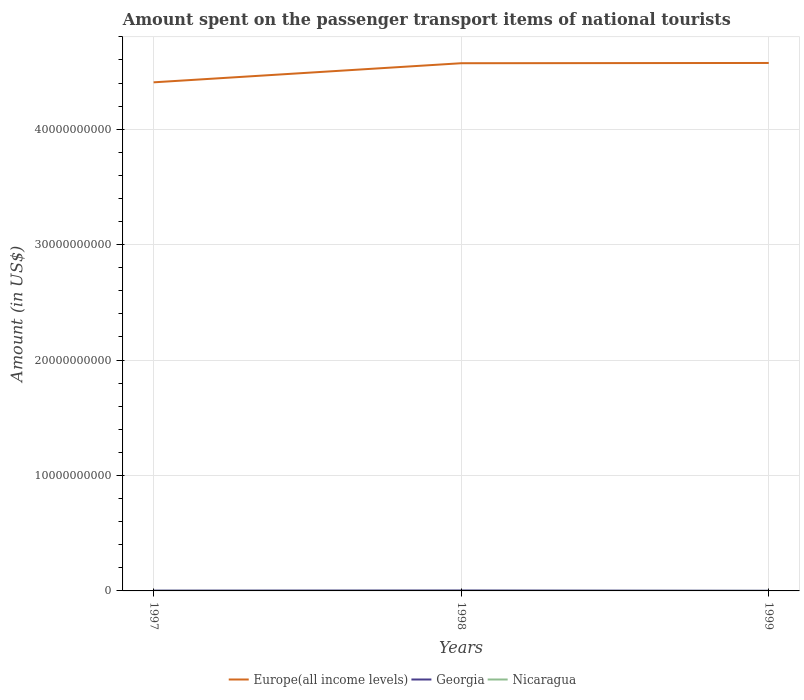Does the line corresponding to Georgia intersect with the line corresponding to Europe(all income levels)?
Keep it short and to the point. No. Across all years, what is the maximum amount spent on the passenger transport items of national tourists in Georgia?
Your answer should be compact. 1.30e+07. What is the total amount spent on the passenger transport items of national tourists in Georgia in the graph?
Keep it short and to the point. 2.80e+07. What is the difference between the highest and the second highest amount spent on the passenger transport items of national tourists in Georgia?
Ensure brevity in your answer.  2.80e+07. Is the amount spent on the passenger transport items of national tourists in Europe(all income levels) strictly greater than the amount spent on the passenger transport items of national tourists in Georgia over the years?
Your response must be concise. No. How many years are there in the graph?
Provide a succinct answer. 3. What is the difference between two consecutive major ticks on the Y-axis?
Offer a terse response. 1.00e+1. Are the values on the major ticks of Y-axis written in scientific E-notation?
Offer a very short reply. No. Does the graph contain any zero values?
Your response must be concise. No. Does the graph contain grids?
Your answer should be very brief. Yes. How are the legend labels stacked?
Keep it short and to the point. Horizontal. What is the title of the graph?
Offer a very short reply. Amount spent on the passenger transport items of national tourists. What is the label or title of the Y-axis?
Provide a short and direct response. Amount (in US$). What is the Amount (in US$) of Europe(all income levels) in 1997?
Provide a succinct answer. 4.41e+1. What is the Amount (in US$) of Georgia in 1997?
Provide a succinct answer. 2.80e+07. What is the Amount (in US$) of Europe(all income levels) in 1998?
Your response must be concise. 4.57e+1. What is the Amount (in US$) in Georgia in 1998?
Provide a succinct answer. 4.10e+07. What is the Amount (in US$) of Europe(all income levels) in 1999?
Keep it short and to the point. 4.57e+1. What is the Amount (in US$) of Georgia in 1999?
Provide a succinct answer. 1.30e+07. What is the Amount (in US$) of Nicaragua in 1999?
Make the answer very short. 3.00e+06. Across all years, what is the maximum Amount (in US$) of Europe(all income levels)?
Make the answer very short. 4.57e+1. Across all years, what is the maximum Amount (in US$) of Georgia?
Provide a succinct answer. 4.10e+07. Across all years, what is the minimum Amount (in US$) in Europe(all income levels)?
Ensure brevity in your answer.  4.41e+1. Across all years, what is the minimum Amount (in US$) of Georgia?
Your answer should be compact. 1.30e+07. What is the total Amount (in US$) of Europe(all income levels) in the graph?
Offer a terse response. 1.36e+11. What is the total Amount (in US$) in Georgia in the graph?
Your response must be concise. 8.20e+07. What is the difference between the Amount (in US$) of Europe(all income levels) in 1997 and that in 1998?
Your answer should be very brief. -1.66e+09. What is the difference between the Amount (in US$) of Georgia in 1997 and that in 1998?
Offer a terse response. -1.30e+07. What is the difference between the Amount (in US$) of Nicaragua in 1997 and that in 1998?
Give a very brief answer. -1.00e+06. What is the difference between the Amount (in US$) in Europe(all income levels) in 1997 and that in 1999?
Offer a very short reply. -1.68e+09. What is the difference between the Amount (in US$) in Georgia in 1997 and that in 1999?
Your answer should be compact. 1.50e+07. What is the difference between the Amount (in US$) of Europe(all income levels) in 1998 and that in 1999?
Keep it short and to the point. -2.19e+07. What is the difference between the Amount (in US$) in Georgia in 1998 and that in 1999?
Offer a very short reply. 2.80e+07. What is the difference between the Amount (in US$) of Europe(all income levels) in 1997 and the Amount (in US$) of Georgia in 1998?
Give a very brief answer. 4.40e+1. What is the difference between the Amount (in US$) of Europe(all income levels) in 1997 and the Amount (in US$) of Nicaragua in 1998?
Offer a very short reply. 4.41e+1. What is the difference between the Amount (in US$) in Georgia in 1997 and the Amount (in US$) in Nicaragua in 1998?
Ensure brevity in your answer.  2.50e+07. What is the difference between the Amount (in US$) in Europe(all income levels) in 1997 and the Amount (in US$) in Georgia in 1999?
Your response must be concise. 4.40e+1. What is the difference between the Amount (in US$) of Europe(all income levels) in 1997 and the Amount (in US$) of Nicaragua in 1999?
Your answer should be compact. 4.41e+1. What is the difference between the Amount (in US$) of Georgia in 1997 and the Amount (in US$) of Nicaragua in 1999?
Make the answer very short. 2.50e+07. What is the difference between the Amount (in US$) in Europe(all income levels) in 1998 and the Amount (in US$) in Georgia in 1999?
Keep it short and to the point. 4.57e+1. What is the difference between the Amount (in US$) in Europe(all income levels) in 1998 and the Amount (in US$) in Nicaragua in 1999?
Provide a succinct answer. 4.57e+1. What is the difference between the Amount (in US$) in Georgia in 1998 and the Amount (in US$) in Nicaragua in 1999?
Offer a terse response. 3.80e+07. What is the average Amount (in US$) of Europe(all income levels) per year?
Make the answer very short. 4.52e+1. What is the average Amount (in US$) of Georgia per year?
Ensure brevity in your answer.  2.73e+07. What is the average Amount (in US$) in Nicaragua per year?
Ensure brevity in your answer.  2.67e+06. In the year 1997, what is the difference between the Amount (in US$) in Europe(all income levels) and Amount (in US$) in Georgia?
Provide a short and direct response. 4.40e+1. In the year 1997, what is the difference between the Amount (in US$) in Europe(all income levels) and Amount (in US$) in Nicaragua?
Make the answer very short. 4.41e+1. In the year 1997, what is the difference between the Amount (in US$) of Georgia and Amount (in US$) of Nicaragua?
Give a very brief answer. 2.60e+07. In the year 1998, what is the difference between the Amount (in US$) of Europe(all income levels) and Amount (in US$) of Georgia?
Your answer should be compact. 4.57e+1. In the year 1998, what is the difference between the Amount (in US$) in Europe(all income levels) and Amount (in US$) in Nicaragua?
Provide a succinct answer. 4.57e+1. In the year 1998, what is the difference between the Amount (in US$) of Georgia and Amount (in US$) of Nicaragua?
Make the answer very short. 3.80e+07. In the year 1999, what is the difference between the Amount (in US$) of Europe(all income levels) and Amount (in US$) of Georgia?
Make the answer very short. 4.57e+1. In the year 1999, what is the difference between the Amount (in US$) of Europe(all income levels) and Amount (in US$) of Nicaragua?
Keep it short and to the point. 4.57e+1. In the year 1999, what is the difference between the Amount (in US$) in Georgia and Amount (in US$) in Nicaragua?
Your response must be concise. 1.00e+07. What is the ratio of the Amount (in US$) in Europe(all income levels) in 1997 to that in 1998?
Keep it short and to the point. 0.96. What is the ratio of the Amount (in US$) in Georgia in 1997 to that in 1998?
Your answer should be very brief. 0.68. What is the ratio of the Amount (in US$) in Nicaragua in 1997 to that in 1998?
Provide a short and direct response. 0.67. What is the ratio of the Amount (in US$) in Europe(all income levels) in 1997 to that in 1999?
Provide a succinct answer. 0.96. What is the ratio of the Amount (in US$) of Georgia in 1997 to that in 1999?
Your answer should be very brief. 2.15. What is the ratio of the Amount (in US$) of Nicaragua in 1997 to that in 1999?
Your answer should be very brief. 0.67. What is the ratio of the Amount (in US$) of Europe(all income levels) in 1998 to that in 1999?
Give a very brief answer. 1. What is the ratio of the Amount (in US$) of Georgia in 1998 to that in 1999?
Make the answer very short. 3.15. What is the ratio of the Amount (in US$) in Nicaragua in 1998 to that in 1999?
Offer a very short reply. 1. What is the difference between the highest and the second highest Amount (in US$) of Europe(all income levels)?
Your answer should be very brief. 2.19e+07. What is the difference between the highest and the second highest Amount (in US$) in Georgia?
Make the answer very short. 1.30e+07. What is the difference between the highest and the lowest Amount (in US$) in Europe(all income levels)?
Keep it short and to the point. 1.68e+09. What is the difference between the highest and the lowest Amount (in US$) of Georgia?
Your response must be concise. 2.80e+07. 